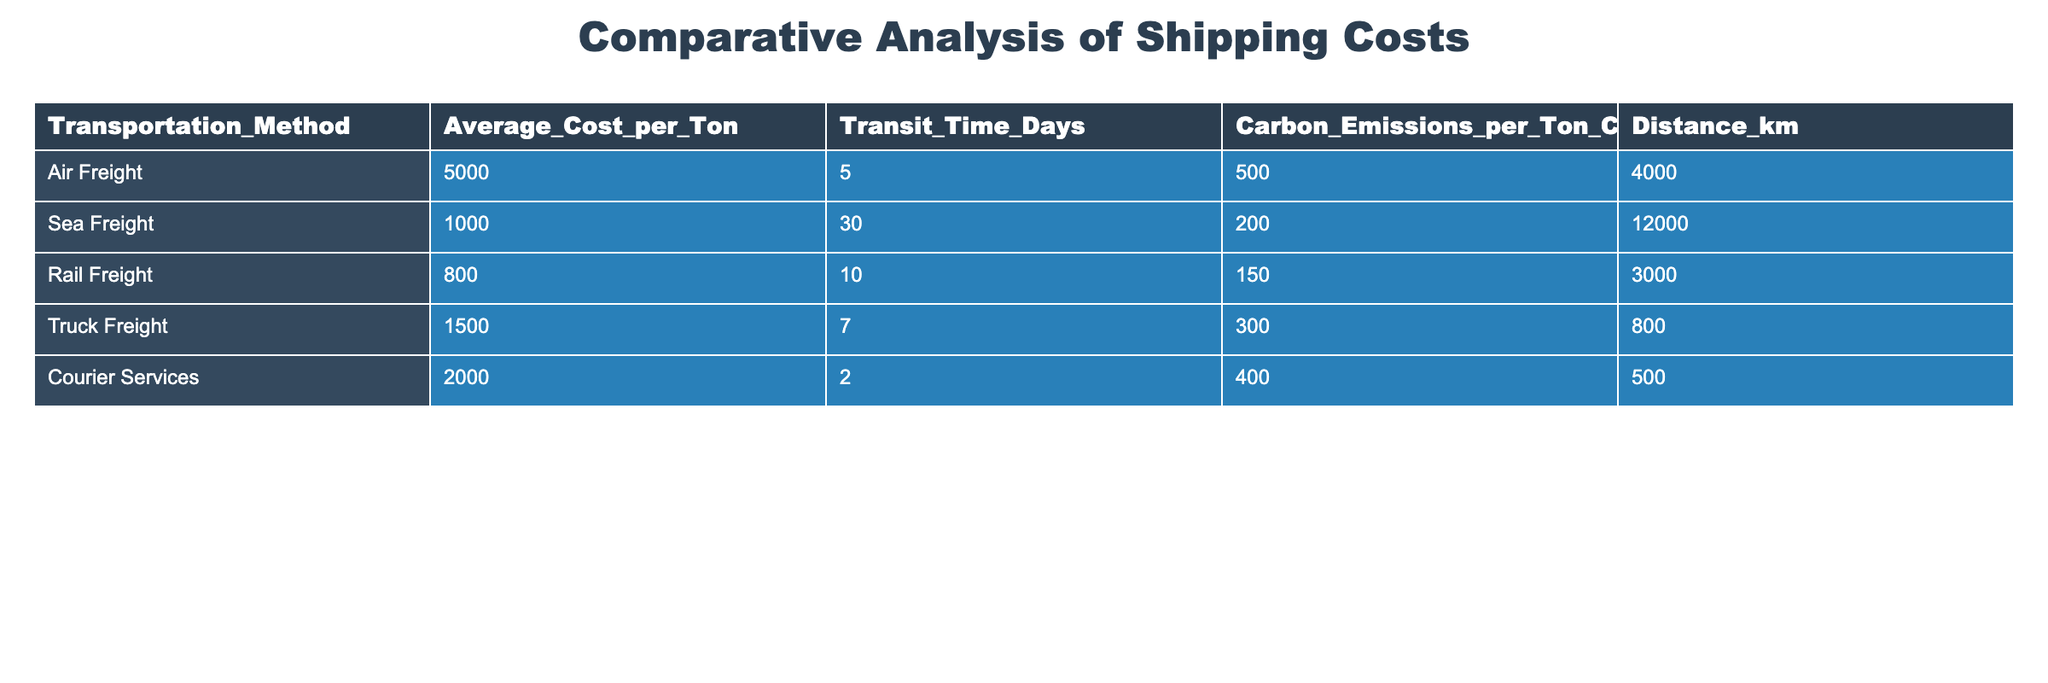What is the Average Cost per Ton for Sea Freight? The table shows the column "Average_Cost_per_Ton" for "Sea Freight" specifically. According to the data, the average cost for Sea Freight is 1000.
Answer: 1000 What transportation method has the lowest Carbon Emissions per Ton CO2? By comparing the values in the "Carbon_Emissions_per_Ton_CO2" column across all transportation methods, Rail Freight has the lowest emissions at 150.
Answer: Rail Freight What is the total Carbon Emissions per Ton CO2 for all transportation methods combined? To find the total carbon emissions, we sum all the values in the "Carbon_Emissions_per_Ton_CO2" column: 500 + 200 + 150 + 300 + 400 = 1550.
Answer: 1550 How much more does Air Freight cost per ton compared to Truck Freight? To find the difference, we subtract Truck Freight cost from Air Freight cost: 5000 - 1500 = 3500. Therefore, Air Freight costs 3500 more than Truck Freight.
Answer: 3500 Is the Transit Time for Courier Services less than 5 days? Looking at the "Transit_Time_Days" column, the value for Courier Services is 2, which is less than 5. Therefore, the statement is true.
Answer: Yes Which transportation method has the highest average cost per ton? By examining the "Average_Cost_per_Ton" column, it is clear that Air Freight, with an average cost of 5000, is the highest among all methods.
Answer: Air Freight What is the difference in Transit Time between Sea Freight and Rail Freight? The Transit Time for Sea Freight is 30 days and for Rail Freight is 10 days. To find the difference, we subtract: 30 - 10 = 20 days.
Answer: 20 days If the distance for Truck Freight is halved, what would the new distance be? The original distance for Truck Freight is 800 km; if it is halved, we calculate: 800 / 2 = 400 km.
Answer: 400 km What is the average Transit Time across all transportation methods? To find the average, we sum the Transit Time (5 + 30 + 10 + 7 + 2 = 54) and then divide by the number of methods (5): 54 / 5 = 10.8 days.
Answer: 10.8 days 